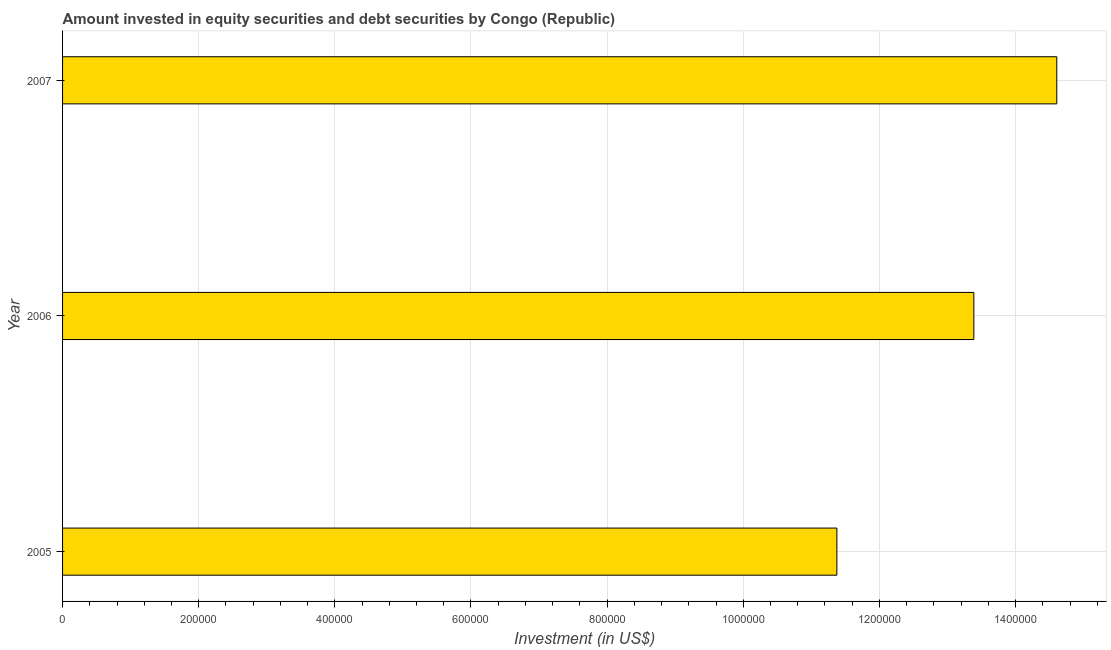Does the graph contain grids?
Offer a terse response. Yes. What is the title of the graph?
Your response must be concise. Amount invested in equity securities and debt securities by Congo (Republic). What is the label or title of the X-axis?
Give a very brief answer. Investment (in US$). What is the portfolio investment in 2005?
Keep it short and to the point. 1.14e+06. Across all years, what is the maximum portfolio investment?
Ensure brevity in your answer.  1.46e+06. Across all years, what is the minimum portfolio investment?
Your answer should be very brief. 1.14e+06. In which year was the portfolio investment minimum?
Keep it short and to the point. 2005. What is the sum of the portfolio investment?
Offer a very short reply. 3.94e+06. What is the difference between the portfolio investment in 2005 and 2007?
Make the answer very short. -3.23e+05. What is the average portfolio investment per year?
Offer a terse response. 1.31e+06. What is the median portfolio investment?
Your answer should be very brief. 1.34e+06. In how many years, is the portfolio investment greater than 40000 US$?
Your answer should be very brief. 3. Do a majority of the years between 2006 and 2005 (inclusive) have portfolio investment greater than 1280000 US$?
Keep it short and to the point. No. What is the ratio of the portfolio investment in 2005 to that in 2007?
Keep it short and to the point. 0.78. Is the portfolio investment in 2005 less than that in 2006?
Offer a very short reply. Yes. What is the difference between the highest and the second highest portfolio investment?
Your response must be concise. 1.22e+05. Is the sum of the portfolio investment in 2005 and 2006 greater than the maximum portfolio investment across all years?
Give a very brief answer. Yes. What is the difference between the highest and the lowest portfolio investment?
Provide a short and direct response. 3.23e+05. In how many years, is the portfolio investment greater than the average portfolio investment taken over all years?
Make the answer very short. 2. Are all the bars in the graph horizontal?
Keep it short and to the point. Yes. Are the values on the major ticks of X-axis written in scientific E-notation?
Your answer should be compact. No. What is the Investment (in US$) in 2005?
Your response must be concise. 1.14e+06. What is the Investment (in US$) of 2006?
Make the answer very short. 1.34e+06. What is the Investment (in US$) of 2007?
Keep it short and to the point. 1.46e+06. What is the difference between the Investment (in US$) in 2005 and 2006?
Provide a short and direct response. -2.01e+05. What is the difference between the Investment (in US$) in 2005 and 2007?
Ensure brevity in your answer.  -3.23e+05. What is the difference between the Investment (in US$) in 2006 and 2007?
Offer a very short reply. -1.22e+05. What is the ratio of the Investment (in US$) in 2005 to that in 2007?
Keep it short and to the point. 0.78. What is the ratio of the Investment (in US$) in 2006 to that in 2007?
Offer a very short reply. 0.92. 